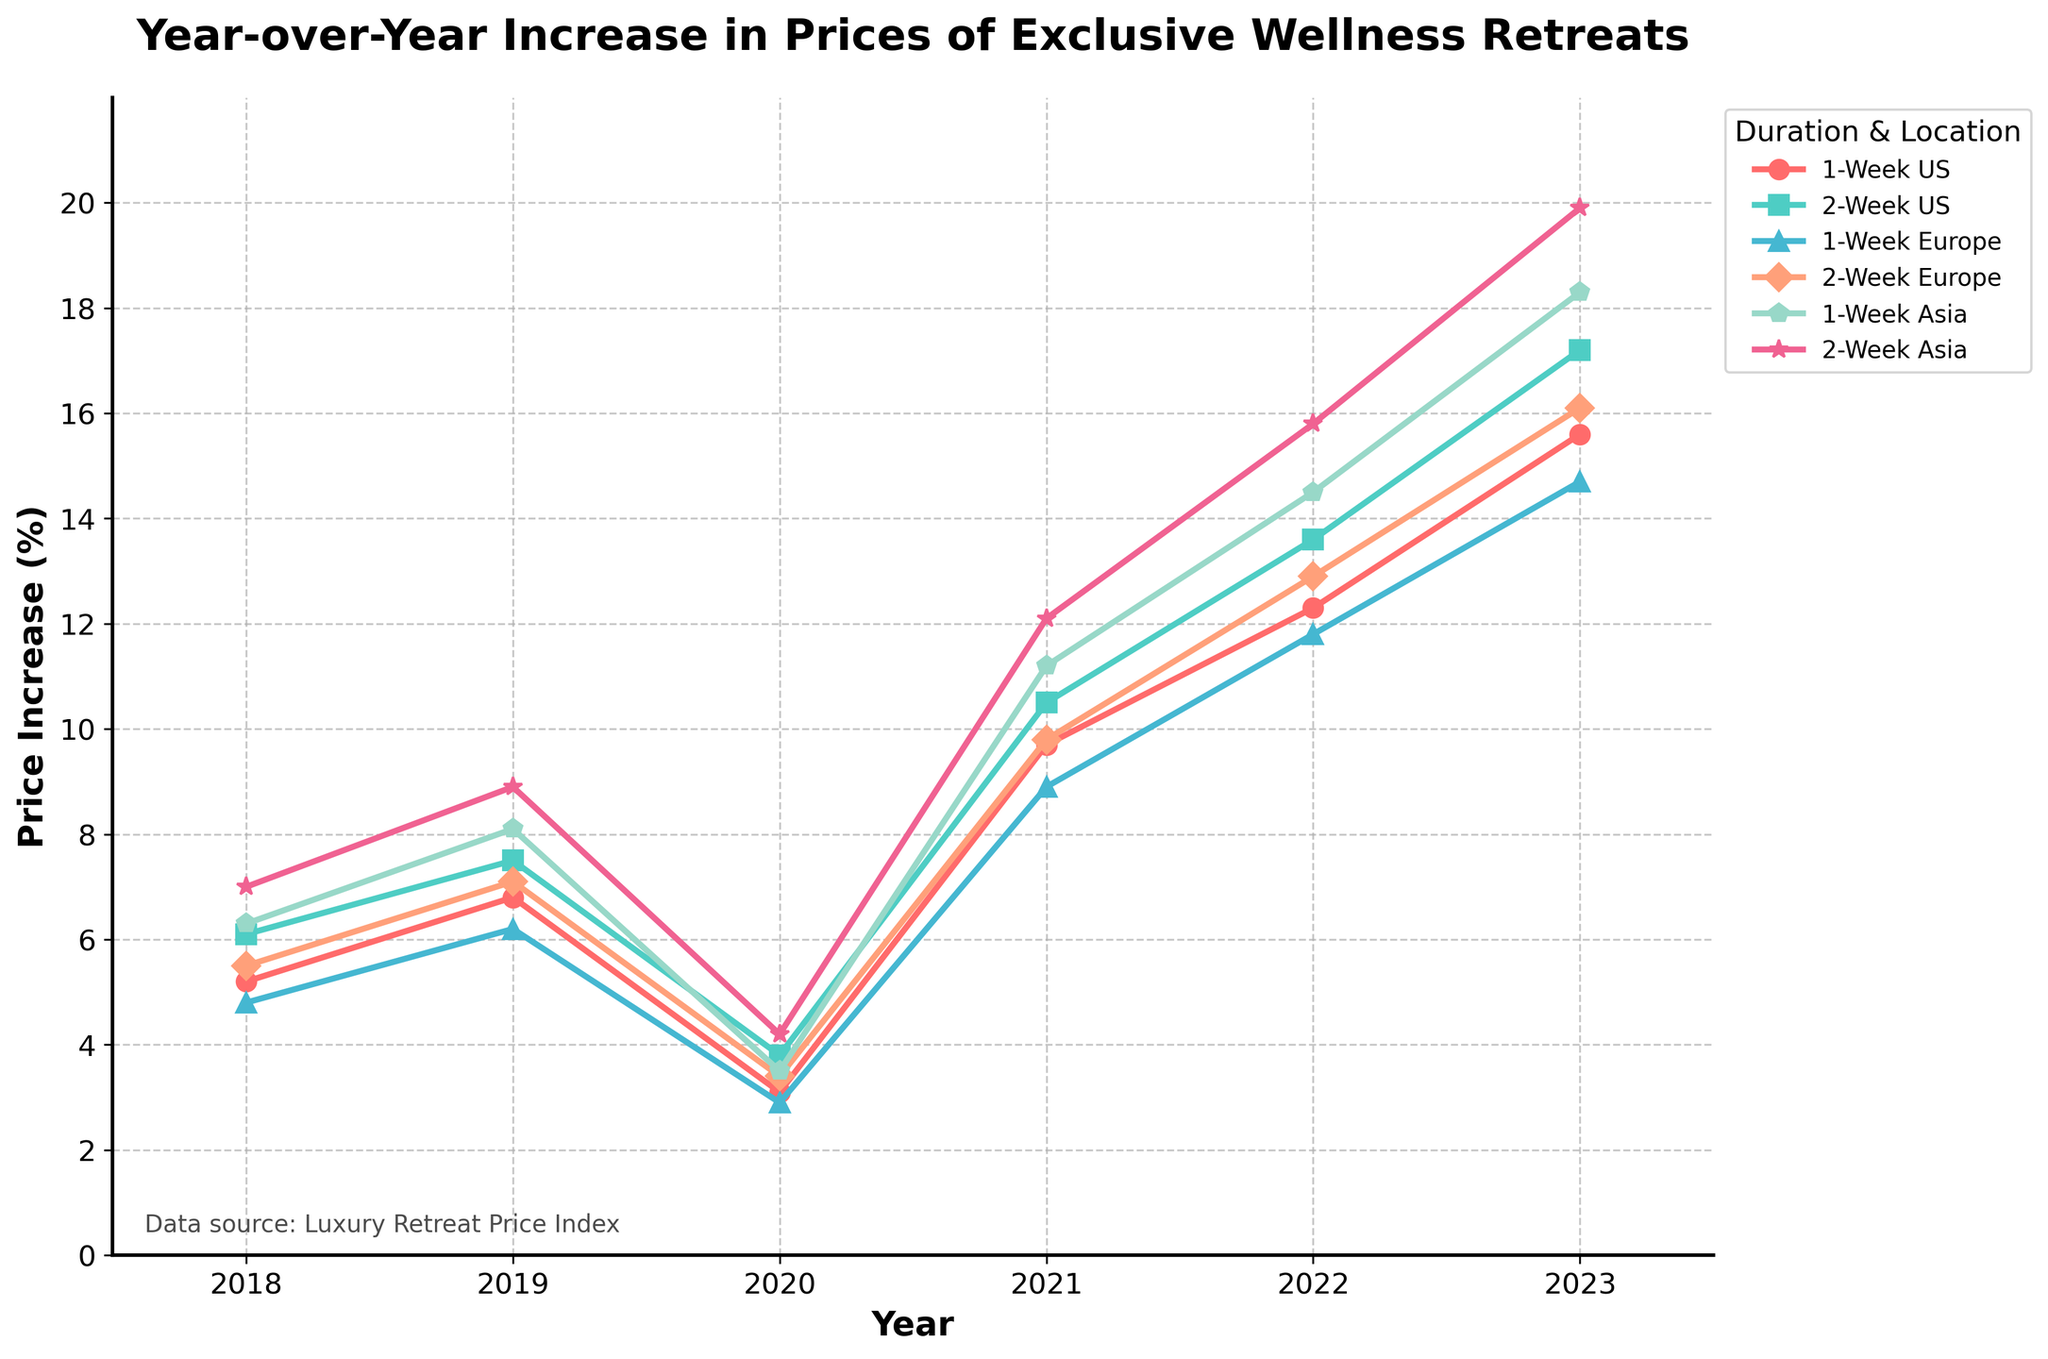What is the overall trend in the prices of 2-Week wellness retreats in Asia from 2018 to 2023? The trend can be analyzed by observing the line representing "2-Week Asia" from 2018 to 2023. The values increase from 7.0 in 2018 to 19.9 in 2023, indicating a consistent upward trend.
Answer: Increasing Which year shows the most significant increase in prices for 1-Week US wellness retreats? By comparing the price increases year-over-year for "1-Week US", the most significant jump occurs between 2020 and 2021, increasing from 3.1 to 9.7 percent.
Answer: 2021 How does the price increase for a 1-Week retreat in Europe in 2023 compare to the price increase for a 1-Week retreat in the US in 2021? In 2023, the 1-Week Europe retreat increase is 14.7%, while in 2021, the 1-Week US retreat increase is 9.7%. Thus, the 2023 Europe price increase is greater.
Answer: Greater What was the average year-over-year increase in prices for 1-Week wellness retreats in Asia from 2018 to 2023? To find the average, sum the year-over-year increases (6.3, 8.1, 3.5, 11.2, 14.5, 18.3) and divide by the number of years (6). Thus, (6.3+8.1+3.5+11.2+14.5+18.3)/6 = 10.65%.
Answer: 10.65% Compare the difference between the price increases of 2-Week US retreats and 1-Week US retreats in the year 2019. In 2019, the 2-Week US retreats increased by 7.5%, and the 1-Week US retreats increased by 6.8%. The difference is 7.5 - 6.8 = 0.7%.
Answer: 0.7% Which duration and location combination experienced the highest percentage increase in prices in 2022? By examining the 2022 data, the highest value is 15.8% for "2-Week Asia".
Answer: 2-Week Asia What can be inferred about the price stability of 1-Week retreats in Europe during the period of 2018 to 2020? Looking at the data, the increase in prices for 1-Week Europe retreats ranges between 2.9% and 6.2%, showing relative stability with less dramatic changes compared to other periods.
Answer: Relatively stable 